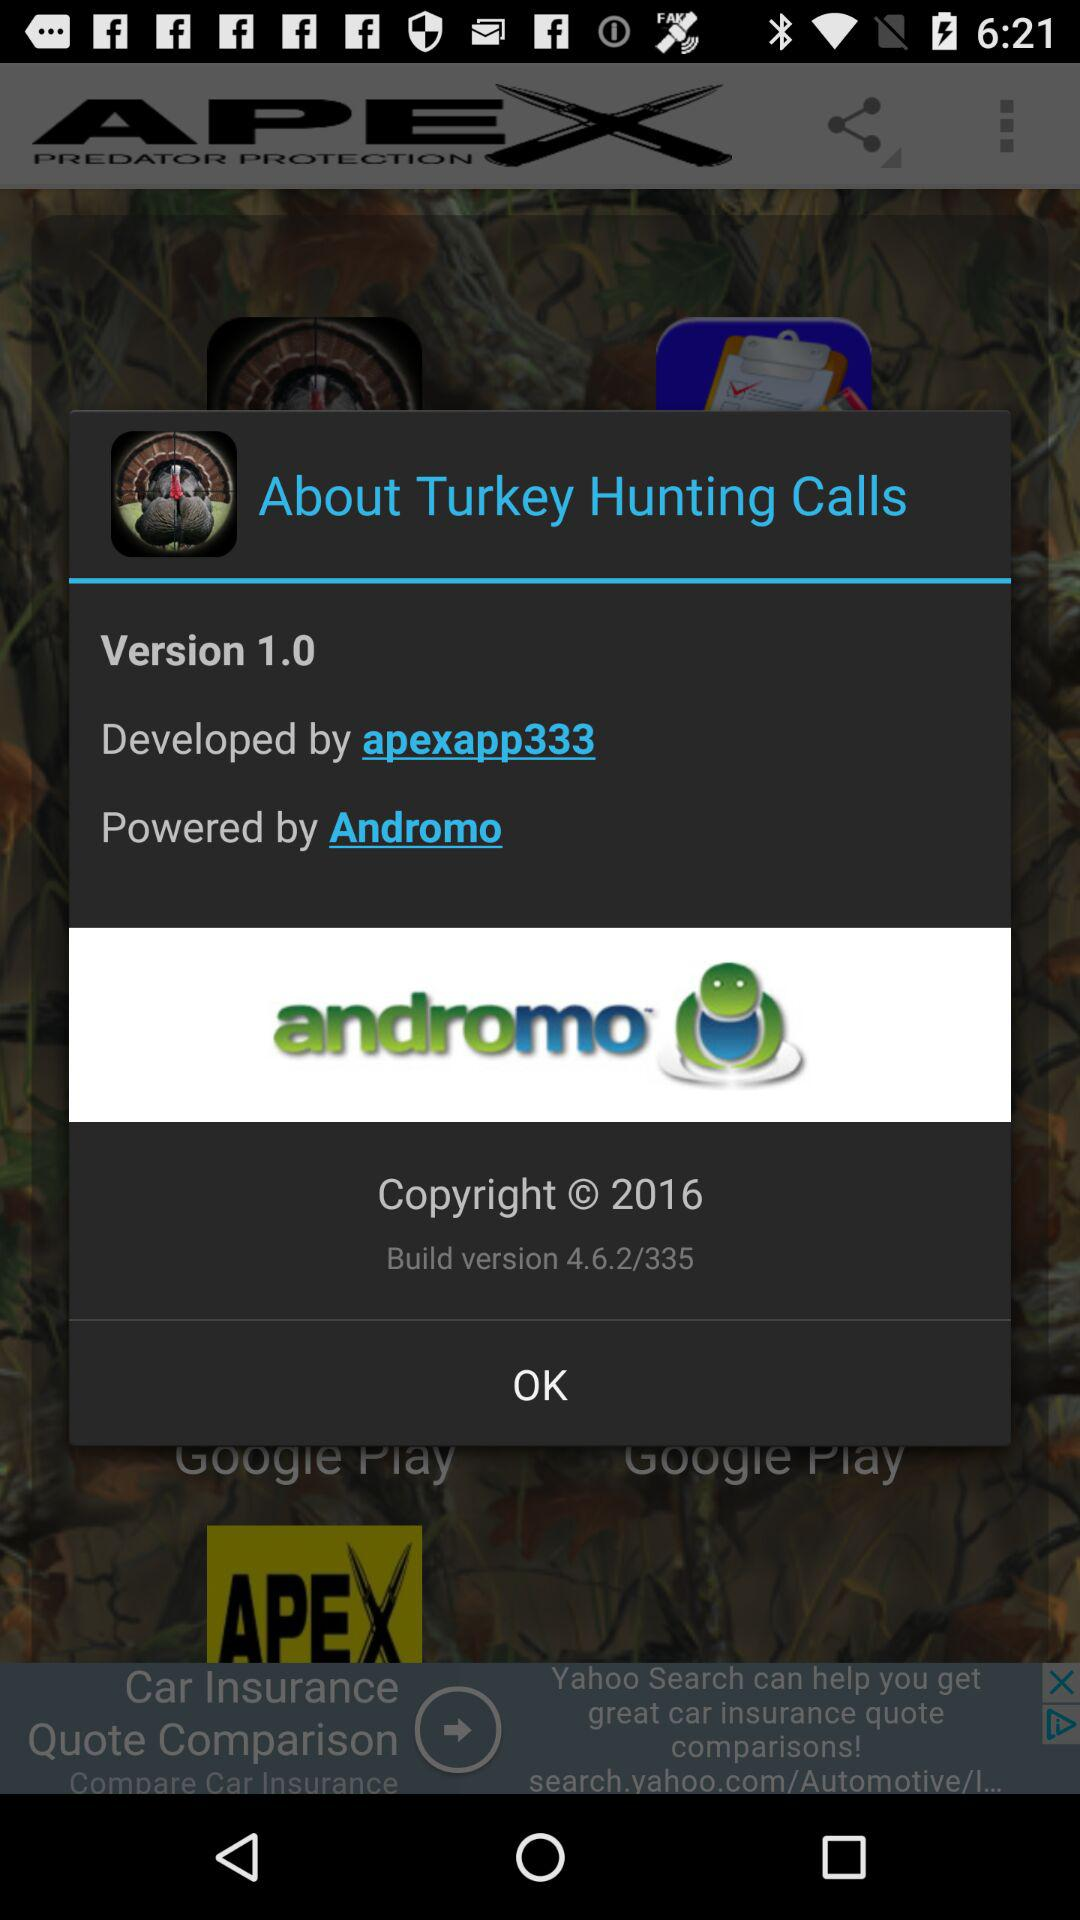What is the copyright year? The copyright year is 2016. 